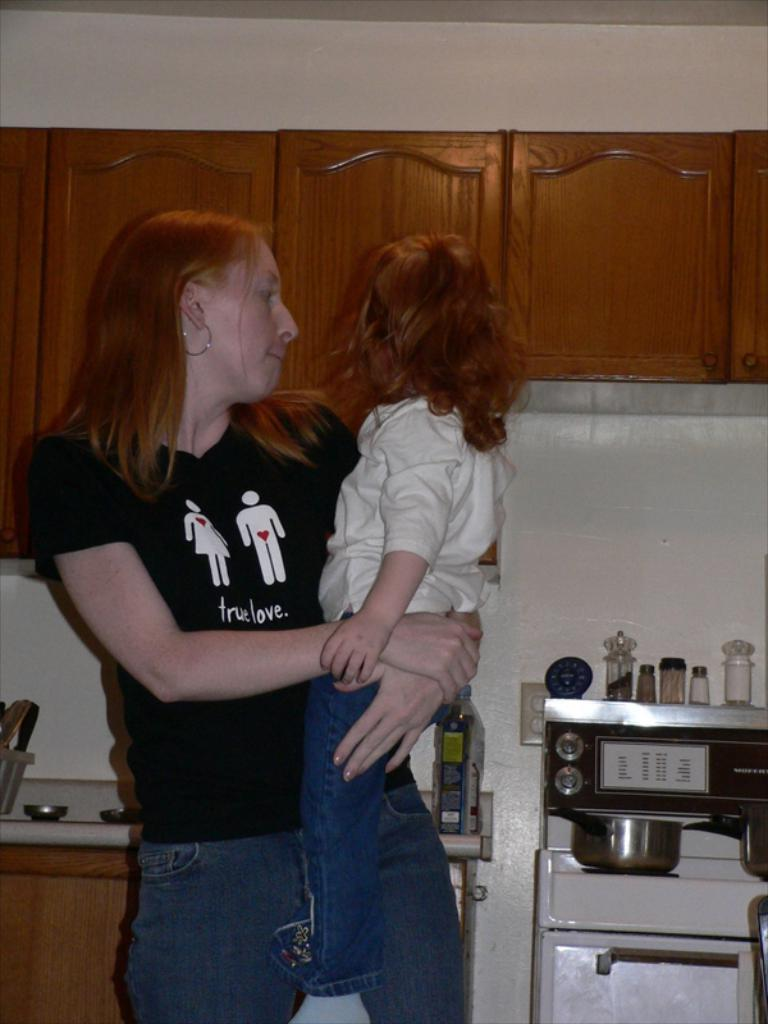<image>
Create a compact narrative representing the image presented. A woman wearing a t-shirt that says true love is holding a little girl in a kitchen. 